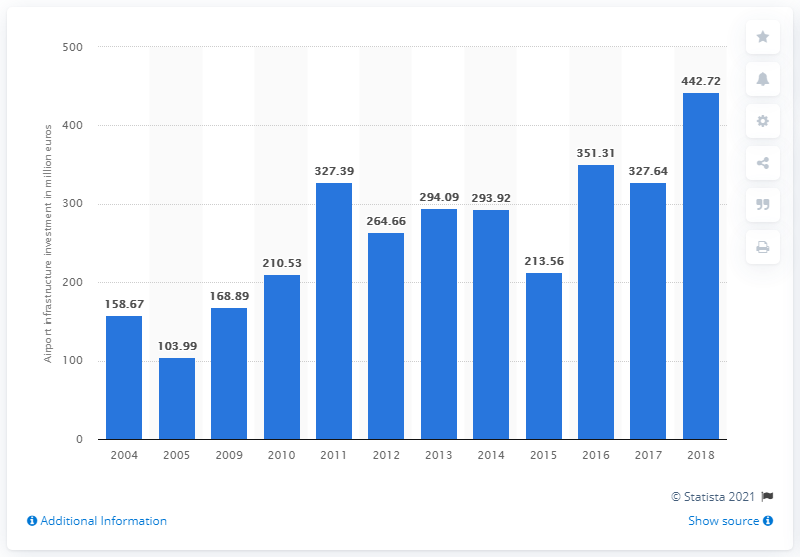Draw attention to some important aspects in this diagram. Between 2004 and 2018, a total of $442.72 was invested in airport infrastructure. 